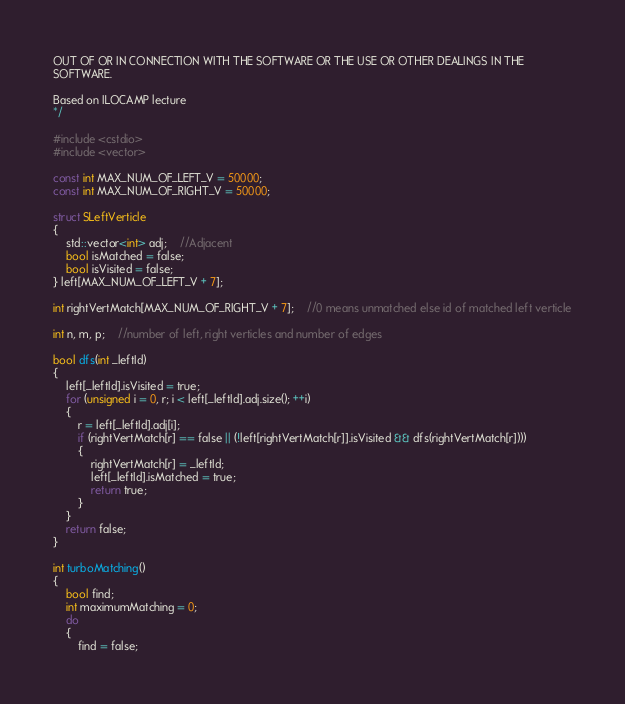<code> <loc_0><loc_0><loc_500><loc_500><_C++_>OUT OF OR IN CONNECTION WITH THE SOFTWARE OR THE USE OR OTHER DEALINGS IN THE
SOFTWARE.

Based on ILOCAMP lecture
*/

#include <cstdio>
#include <vector>

const int MAX_NUM_OF_LEFT_V = 50000;
const int MAX_NUM_OF_RIGHT_V = 50000;

struct SLeftVerticle
{
	std::vector<int> adj;	//Adjacent
	bool isMatched = false;
	bool isVisited = false;
} left[MAX_NUM_OF_LEFT_V + 7];

int rightVertMatch[MAX_NUM_OF_RIGHT_V + 7];	//0 means unmatched else id of matched left verticle

int n, m, p;	//number of left, right verticles and number of edges

bool dfs(int _leftId)
{
	left[_leftId].isVisited = true;
	for (unsigned i = 0, r; i < left[_leftId].adj.size(); ++i)
	{
		r = left[_leftId].adj[i];
		if (rightVertMatch[r] == false || (!left[rightVertMatch[r]].isVisited && dfs(rightVertMatch[r])))
		{
			rightVertMatch[r] = _leftId;
			left[_leftId].isMatched = true;
			return true;
		}
	}
	return false;
}

int turboMatching()
{
	bool find;
	int maximumMatching = 0;
	do
	{
		find = false;</code> 